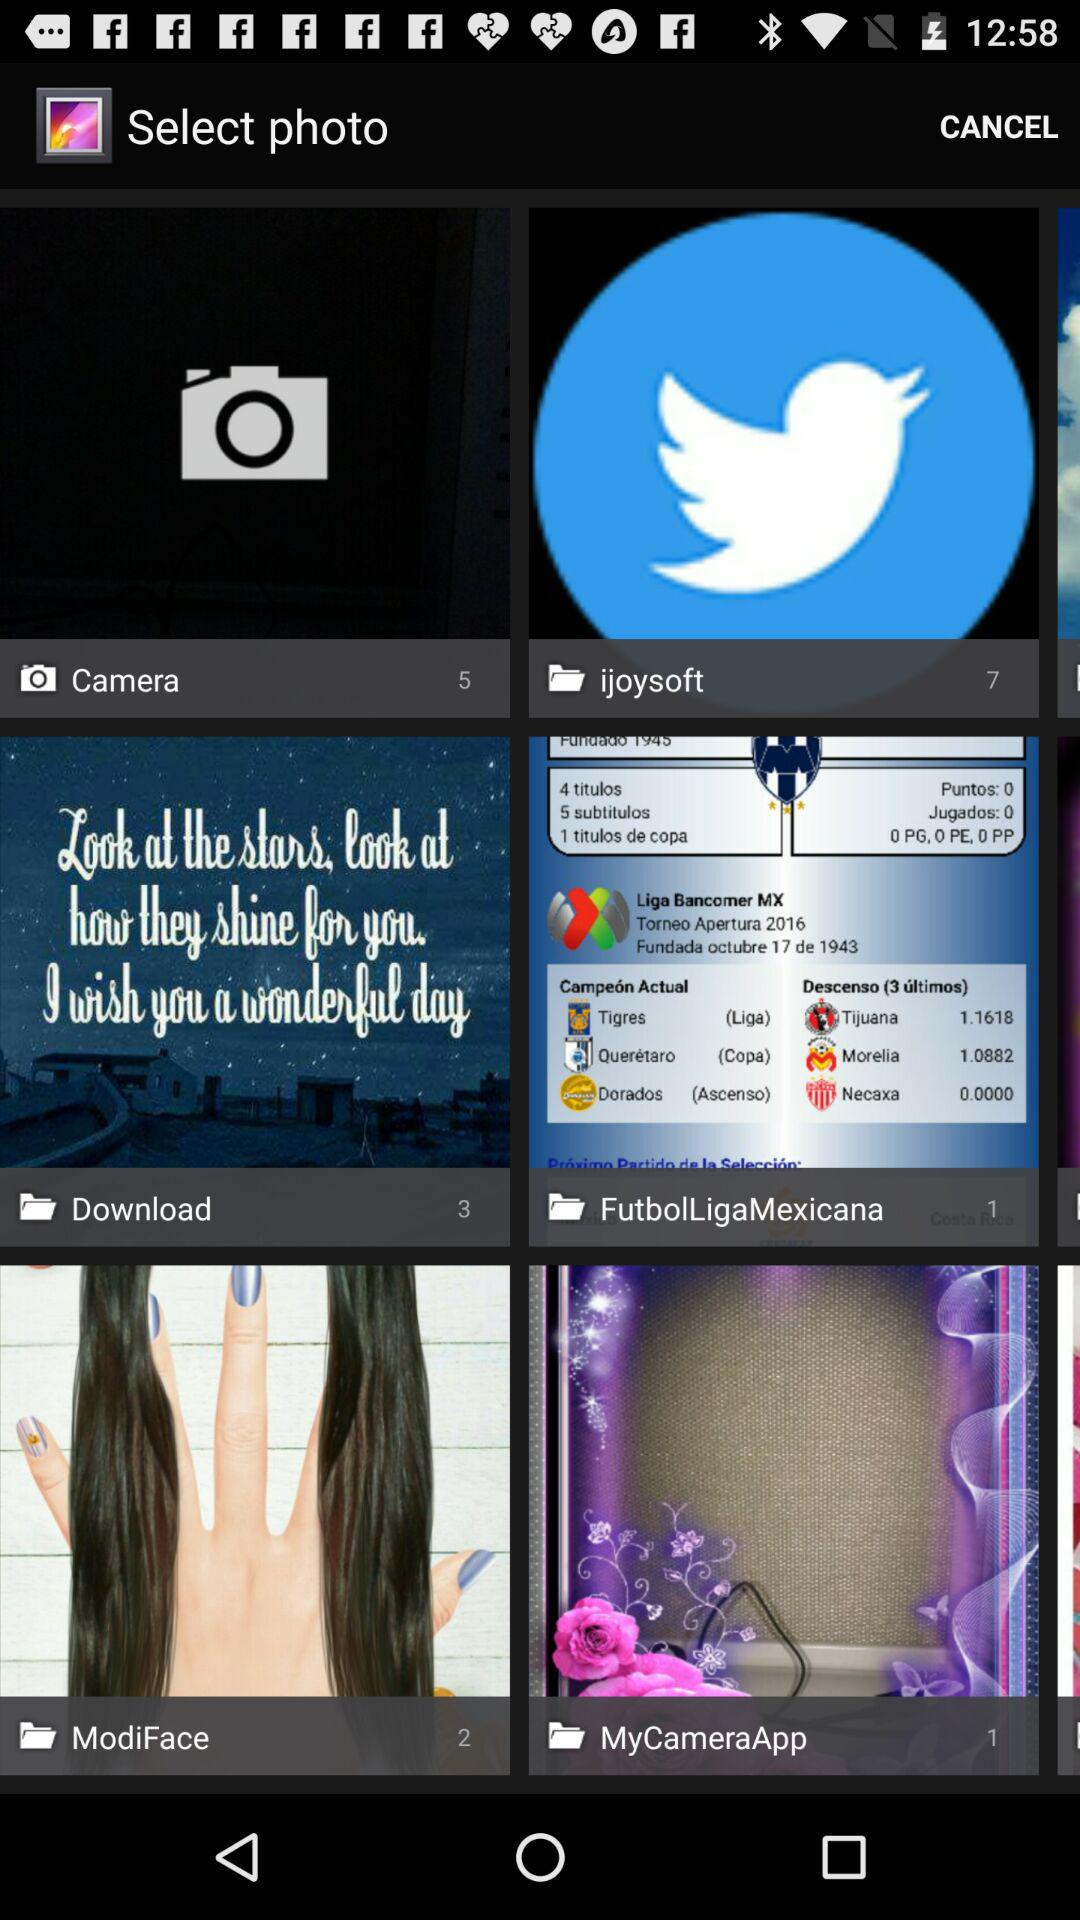What is the count of photos in "Camera"? The count of photos in "Camera" is 5. 